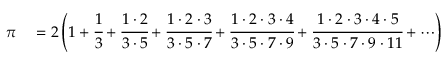<formula> <loc_0><loc_0><loc_500><loc_500>\begin{array} { r l } { \pi } & = 2 \left ( 1 + { \cfrac { 1 } { 3 } } + { \cfrac { 1 \cdot 2 } { 3 \cdot 5 } } + { \cfrac { 1 \cdot 2 \cdot 3 } { 3 \cdot 5 \cdot 7 } } + { \cfrac { 1 \cdot 2 \cdot 3 \cdot 4 } { 3 \cdot 5 \cdot 7 \cdot 9 } } + { \cfrac { 1 \cdot 2 \cdot 3 \cdot 4 \cdot 5 } { 3 \cdot 5 \cdot 7 \cdot 9 \cdot 1 1 } } + \cdots \right ) } \end{array}</formula> 